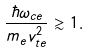<formula> <loc_0><loc_0><loc_500><loc_500>\frac { \hbar { \omega } _ { c e } } { m _ { e } v _ { t e } ^ { 2 } } \gtrsim 1 .</formula> 